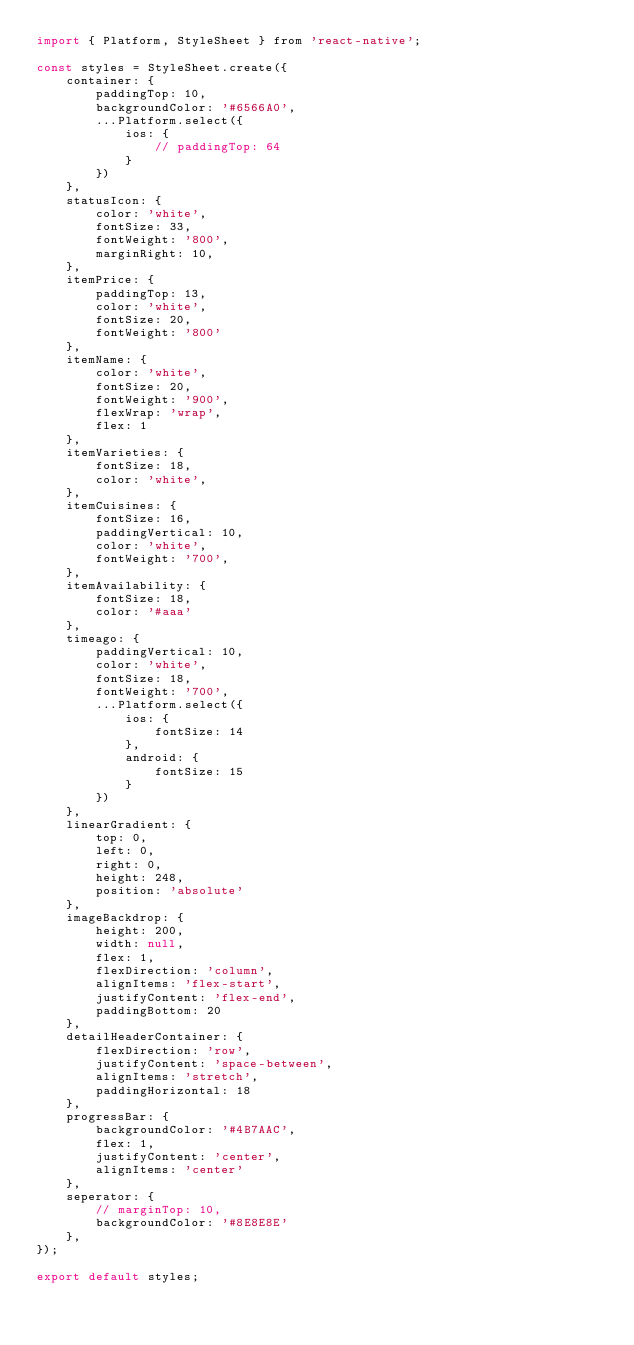Convert code to text. <code><loc_0><loc_0><loc_500><loc_500><_JavaScript_>import { Platform, StyleSheet } from 'react-native';

const styles = StyleSheet.create({
    container: {
        paddingTop: 10,
        backgroundColor: '#6566A0',
        ...Platform.select({
            ios: {
                // paddingTop: 64
            }
        })
    },
    statusIcon: {
        color: 'white',
        fontSize: 33,
        fontWeight: '800',
        marginRight: 10,
    },
    itemPrice: {
        paddingTop: 13,
        color: 'white',
        fontSize: 20,
        fontWeight: '800'
    },
    itemName: {
        color: 'white',
        fontSize: 20,
        fontWeight: '900',
        flexWrap: 'wrap',
        flex: 1
    },
    itemVarieties: {
        fontSize: 18,
        color: 'white',
    },
    itemCuisines: {
        fontSize: 16,
        paddingVertical: 10,
        color: 'white',
        fontWeight: '700',
    },
    itemAvailability: {
        fontSize: 18,
        color: '#aaa'
    },
    timeago: {
        paddingVertical: 10,
        color: 'white',
        fontSize: 18,
        fontWeight: '700',
        ...Platform.select({
            ios: {
                fontSize: 14
            },
            android: {
                fontSize: 15
            }
        })
    },
    linearGradient: {
        top: 0,
        left: 0,
        right: 0,
        height: 248,
        position: 'absolute'
    },
    imageBackdrop: {
        height: 200,
        width: null,
        flex: 1,
        flexDirection: 'column',
        alignItems: 'flex-start',
        justifyContent: 'flex-end',
        paddingBottom: 20
    },
    detailHeaderContainer: {
        flexDirection: 'row',
        justifyContent: 'space-between',
        alignItems: 'stretch',
        paddingHorizontal: 18
    },
    progressBar: {
        backgroundColor: '#4B7AAC',
        flex: 1,
        justifyContent: 'center',
        alignItems: 'center'
    },
    seperator: {
        // marginTop: 10,
        backgroundColor: '#8E8E8E'
    },
});

export default styles;
</code> 